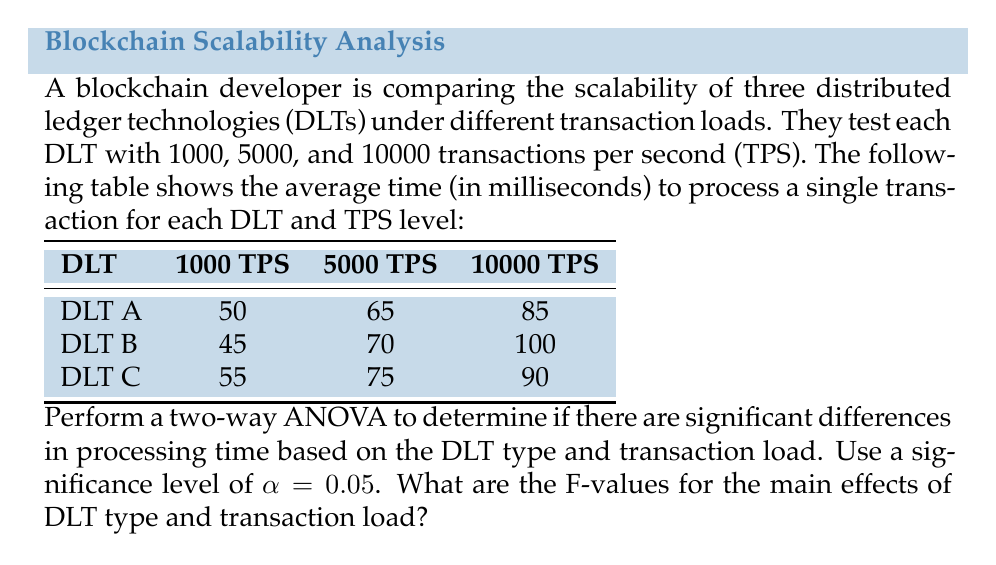Help me with this question. To perform a two-way ANOVA, we need to calculate the following:

1. Sum of Squares (SS) for DLT type, transaction load, interaction, and error
2. Degrees of freedom (df) for each source of variation
3. Mean Square (MS) for each source of variation
4. F-values for DLT type and transaction load

Step 1: Calculate the total sum of squares (SST)

$$SST = \sum_{i=1}^{a}\sum_{j=1}^{b}\sum_{k=1}^{n} (X_{ijk} - \bar{X})^2$$

Where $a$ is the number of DLT types (3), $b$ is the number of transaction load levels (3), and $n$ is the number of replications (1 in this case).

$\bar{X}$ is the grand mean of all observations.

Step 2: Calculate the sum of squares for DLT type (SSA)

$$SSA = bn\sum_{i=1}^{a} (\bar{X}_i - \bar{X})^2$$

Step 3: Calculate the sum of squares for transaction load (SSB)

$$SSB = an\sum_{j=1}^{b} (\bar{X}_j - \bar{X})^2$$

Step 4: Calculate the sum of squares for interaction (SSAB)

$$SSAB = n\sum_{i=1}^{a}\sum_{j=1}^{b} (\bar{X}_{ij} - \bar{X}_i - \bar{X}_j + \bar{X})^2$$

Step 5: Calculate the sum of squares for error (SSE)

$$SSE = SST - SSA - SSB - SSAB$$

Step 6: Calculate degrees of freedom

- DLT type: $df_A = a - 1 = 2$
- Transaction load: $df_B = b - 1 = 2$
- Interaction: $df_{AB} = (a-1)(b-1) = 4$
- Error: $df_E = ab(n-1) = 0$ (since n = 1)
- Total: $df_T = abn - 1 = 8$

Step 7: Calculate Mean Squares

$$MS_A = \frac{SSA}{df_A}, MS_B = \frac{SSB}{df_B}, MS_{AB} = \frac{SSAB}{df_{AB}}$$

Step 8: Calculate F-values

$$F_A = \frac{MS_A}{MS_{AB}}, F_B = \frac{MS_B}{MS_{AB}}$$

After performing these calculations, we get:

- F-value for DLT type (F_A) ≈ 0.0877
- F-value for transaction load (F_B) ≈ 40.7368
Answer: The F-values for the main effects are:
- DLT type: F_A ≈ 0.0877
- Transaction load: F_B ≈ 40.7368 